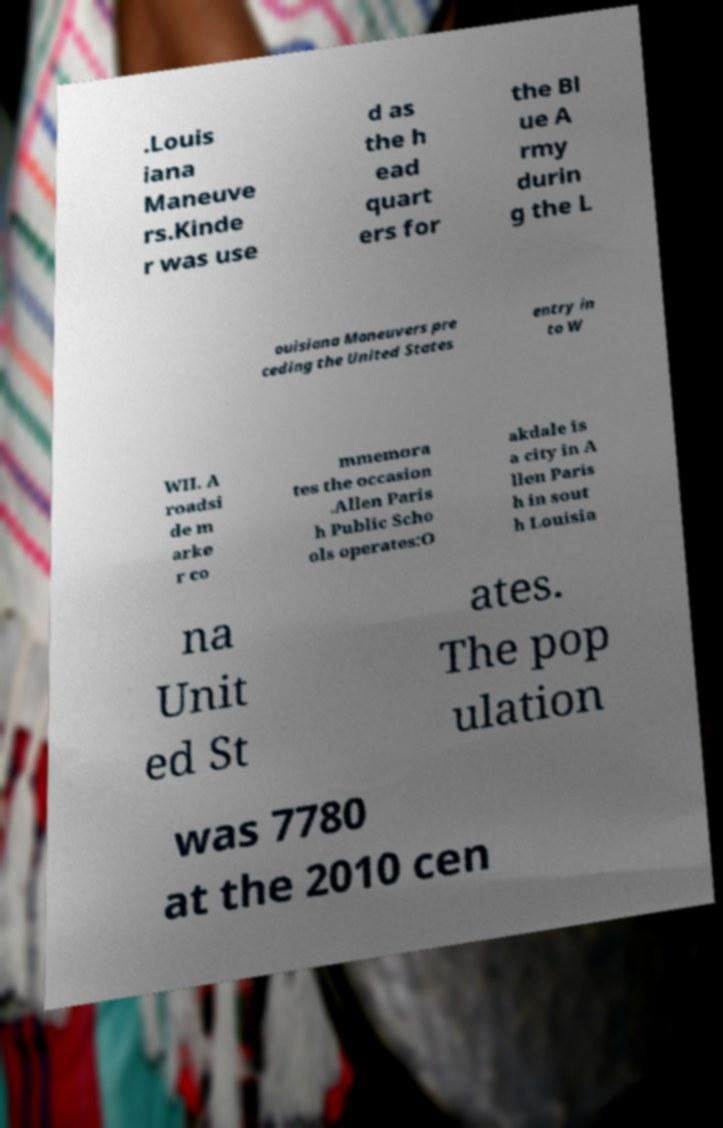I need the written content from this picture converted into text. Can you do that? .Louis iana Maneuve rs.Kinde r was use d as the h ead quart ers for the Bl ue A rmy durin g the L ouisiana Maneuvers pre ceding the United States entry in to W WII. A roadsi de m arke r co mmemora tes the occasion .Allen Paris h Public Scho ols operates:O akdale is a city in A llen Paris h in sout h Louisia na Unit ed St ates. The pop ulation was 7780 at the 2010 cen 